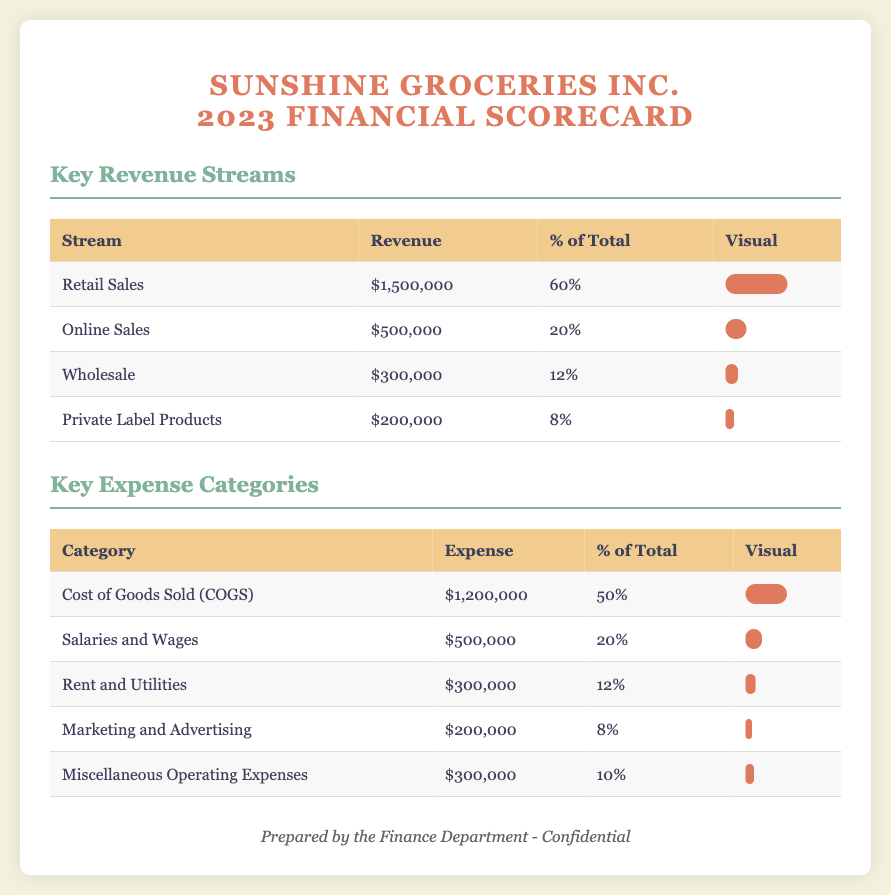What is the total revenue from Retail Sales? The total revenue from Retail Sales is listed as $1,500,000 in the document.
Answer: $1,500,000 What is the percentage share of Online Sales in total revenue? The percentage share of Online Sales is 20%, as indicated in the revenue streams table.
Answer: 20% What is the total Cost of Goods Sold? The total Cost of Goods Sold is given as $1,200,000 in the expense categories section.
Answer: $1,200,000 Which expense category has the highest percentage of total expenses? Cost of Goods Sold (COGS) has the highest percentage, which is 50%.
Answer: 50% What is the total revenue generated from Wholesale? The revenue generated from Wholesale is stated to be $300,000 in the document.
Answer: $300,000 What is the total expense incurred in Marketing and Advertising? The total expense for Marketing and Advertising is reported as $200,000.
Answer: $200,000 What is the combined total of Retail Sales and Online Sales? The combined total is calculated from Retail Sales ($1,500,000) and Online Sales ($500,000), which equals $2,000,000.
Answer: $2,000,000 Which revenue stream accounts for 8% of total revenue? Private Label Products account for 8% of total revenue according to the document.
Answer: Private Label Products What is the total expenditure for Salaries and Wages? The total expenditure for Salaries and Wages is noted as $500,000.
Answer: $500,000 What is the total percentage of Miscellaneous Operating Expenses? The total percentage for Miscellaneous Operating Expenses is indicated as 10% in the scorecard.
Answer: 10% 